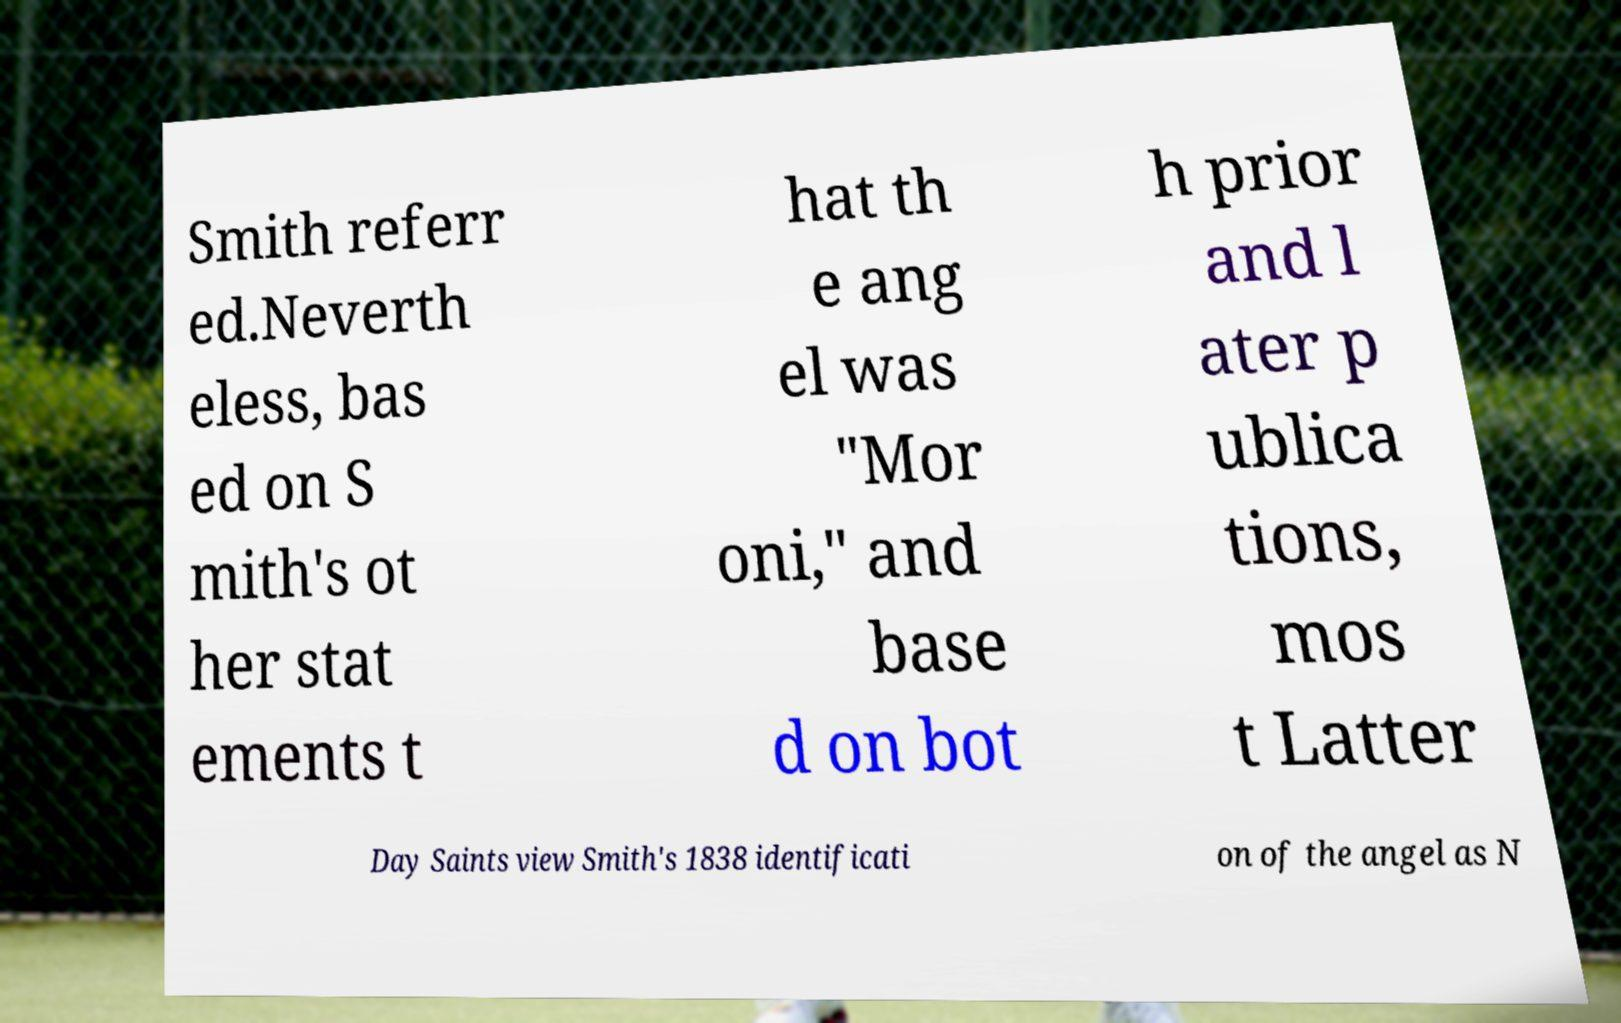Could you assist in decoding the text presented in this image and type it out clearly? Smith referr ed.Neverth eless, bas ed on S mith's ot her stat ements t hat th e ang el was "Mor oni," and base d on bot h prior and l ater p ublica tions, mos t Latter Day Saints view Smith's 1838 identificati on of the angel as N 